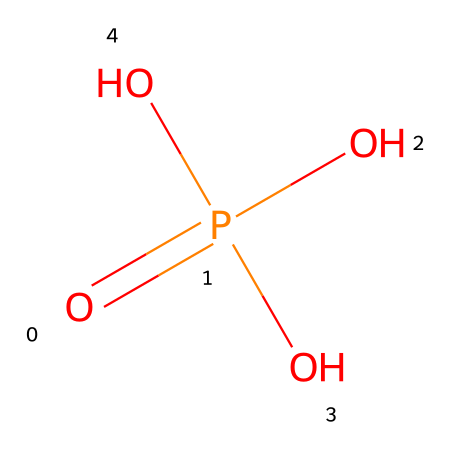What is the molecular formula of this compound? The given SMILES representation shows four oxygen atoms (O), one phosphorus atom (P), and since they are in a phosphoric acid arrangement, the molecular formula can be directly identified as H3PO4.
Answer: H3PO4 How many hydroxyl groups are present in this compound? Looking at the structure, there are three oxygen atoms bonded to hydrogen atoms, which indicates three hydroxyl groups (-OH) in phosphoric acid.
Answer: 3 What is the oxidation state of phosphorus in this compound? To find the oxidation state, we consider that the total charge of phosphoric acid is neutral. Phosphorus is bonded with four oxygens, where three are in -1 state and one in a double bond leads to phosphorus being assigned a +5 oxidation state.
Answer: +5 What type of acid is phosphoric acid? Phosphoric acid is categorized as a triprotic acid as it can donate three protons (H+) in solution due to the presence of three hydroxyl (-OH) groups.
Answer: triprotic What is the hybridization of the phosphorus atom in this compound? In phosphoric acid, the phosphorus atom is bonded to four other atoms (counting the double bond), which suggests it has a tetrahedral geometry; thus, the hybridization is sp3.
Answer: sp3 What type of compound is formed when phosphoric acid reacts with an alcohol? When phosphoric acid reacts with an alcohol, an ester is formed through a dehydration reaction, which typically involves the formation of phosphate esters.
Answer: ester 